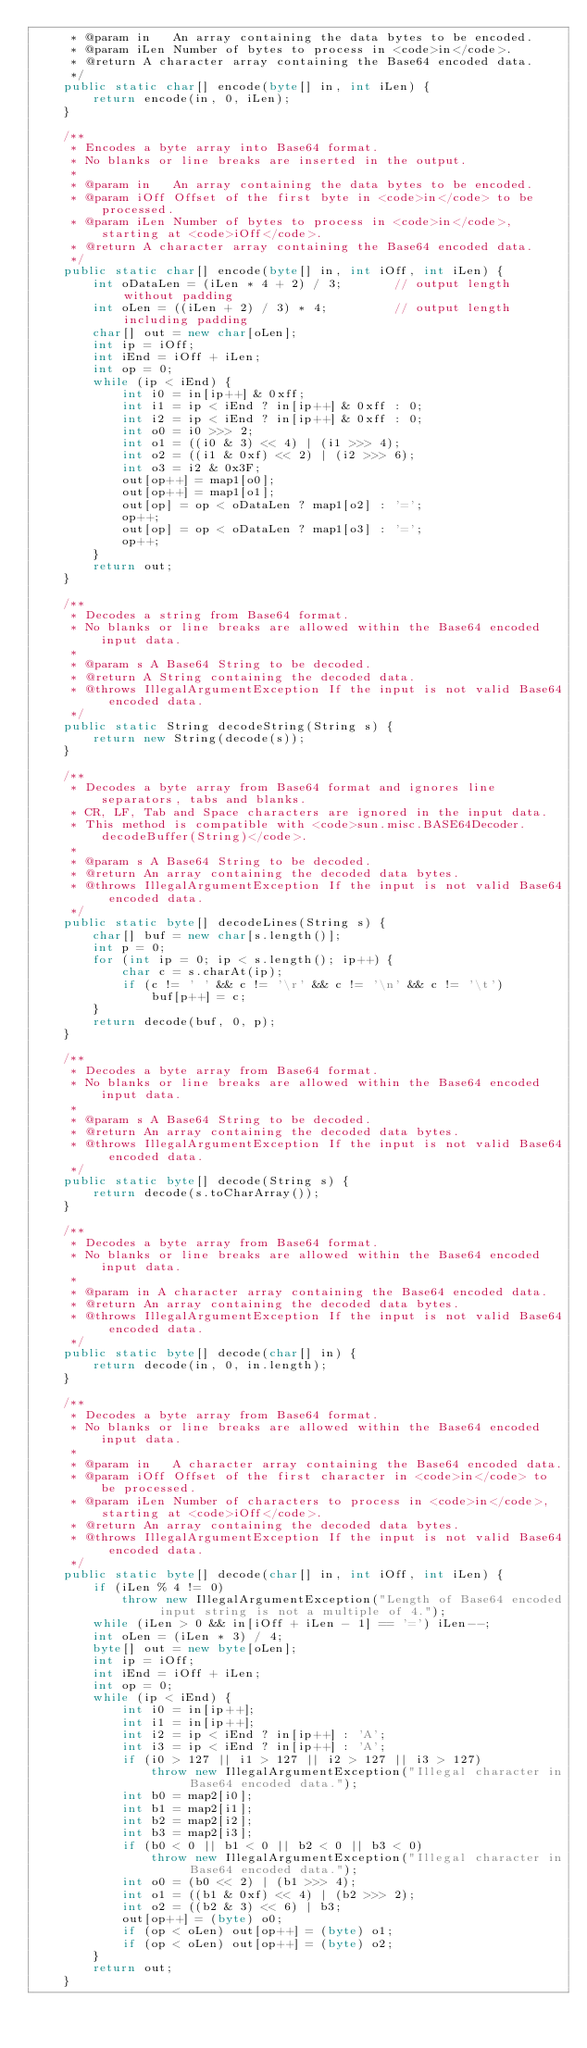<code> <loc_0><loc_0><loc_500><loc_500><_Java_>     * @param in   An array containing the data bytes to be encoded.
     * @param iLen Number of bytes to process in <code>in</code>.
     * @return A character array containing the Base64 encoded data.
     */
    public static char[] encode(byte[] in, int iLen) {
        return encode(in, 0, iLen);
    }

    /**
     * Encodes a byte array into Base64 format.
     * No blanks or line breaks are inserted in the output.
     *
     * @param in   An array containing the data bytes to be encoded.
     * @param iOff Offset of the first byte in <code>in</code> to be processed.
     * @param iLen Number of bytes to process in <code>in</code>, starting at <code>iOff</code>.
     * @return A character array containing the Base64 encoded data.
     */
    public static char[] encode(byte[] in, int iOff, int iLen) {
        int oDataLen = (iLen * 4 + 2) / 3;       // output length without padding
        int oLen = ((iLen + 2) / 3) * 4;         // output length including padding
        char[] out = new char[oLen];
        int ip = iOff;
        int iEnd = iOff + iLen;
        int op = 0;
        while (ip < iEnd) {
            int i0 = in[ip++] & 0xff;
            int i1 = ip < iEnd ? in[ip++] & 0xff : 0;
            int i2 = ip < iEnd ? in[ip++] & 0xff : 0;
            int o0 = i0 >>> 2;
            int o1 = ((i0 & 3) << 4) | (i1 >>> 4);
            int o2 = ((i1 & 0xf) << 2) | (i2 >>> 6);
            int o3 = i2 & 0x3F;
            out[op++] = map1[o0];
            out[op++] = map1[o1];
            out[op] = op < oDataLen ? map1[o2] : '=';
            op++;
            out[op] = op < oDataLen ? map1[o3] : '=';
            op++;
        }
        return out;
    }

    /**
     * Decodes a string from Base64 format.
     * No blanks or line breaks are allowed within the Base64 encoded input data.
     *
     * @param s A Base64 String to be decoded.
     * @return A String containing the decoded data.
     * @throws IllegalArgumentException If the input is not valid Base64 encoded data.
     */
    public static String decodeString(String s) {
        return new String(decode(s));
    }

    /**
     * Decodes a byte array from Base64 format and ignores line separators, tabs and blanks.
     * CR, LF, Tab and Space characters are ignored in the input data.
     * This method is compatible with <code>sun.misc.BASE64Decoder.decodeBuffer(String)</code>.
     *
     * @param s A Base64 String to be decoded.
     * @return An array containing the decoded data bytes.
     * @throws IllegalArgumentException If the input is not valid Base64 encoded data.
     */
    public static byte[] decodeLines(String s) {
        char[] buf = new char[s.length()];
        int p = 0;
        for (int ip = 0; ip < s.length(); ip++) {
            char c = s.charAt(ip);
            if (c != ' ' && c != '\r' && c != '\n' && c != '\t')
                buf[p++] = c;
        }
        return decode(buf, 0, p);
    }

    /**
     * Decodes a byte array from Base64 format.
     * No blanks or line breaks are allowed within the Base64 encoded input data.
     *
     * @param s A Base64 String to be decoded.
     * @return An array containing the decoded data bytes.
     * @throws IllegalArgumentException If the input is not valid Base64 encoded data.
     */
    public static byte[] decode(String s) {
        return decode(s.toCharArray());
    }

    /**
     * Decodes a byte array from Base64 format.
     * No blanks or line breaks are allowed within the Base64 encoded input data.
     *
     * @param in A character array containing the Base64 encoded data.
     * @return An array containing the decoded data bytes.
     * @throws IllegalArgumentException If the input is not valid Base64 encoded data.
     */
    public static byte[] decode(char[] in) {
        return decode(in, 0, in.length);
    }

    /**
     * Decodes a byte array from Base64 format.
     * No blanks or line breaks are allowed within the Base64 encoded input data.
     *
     * @param in   A character array containing the Base64 encoded data.
     * @param iOff Offset of the first character in <code>in</code> to be processed.
     * @param iLen Number of characters to process in <code>in</code>, starting at <code>iOff</code>.
     * @return An array containing the decoded data bytes.
     * @throws IllegalArgumentException If the input is not valid Base64 encoded data.
     */
    public static byte[] decode(char[] in, int iOff, int iLen) {
        if (iLen % 4 != 0)
            throw new IllegalArgumentException("Length of Base64 encoded input string is not a multiple of 4.");
        while (iLen > 0 && in[iOff + iLen - 1] == '=') iLen--;
        int oLen = (iLen * 3) / 4;
        byte[] out = new byte[oLen];
        int ip = iOff;
        int iEnd = iOff + iLen;
        int op = 0;
        while (ip < iEnd) {
            int i0 = in[ip++];
            int i1 = in[ip++];
            int i2 = ip < iEnd ? in[ip++] : 'A';
            int i3 = ip < iEnd ? in[ip++] : 'A';
            if (i0 > 127 || i1 > 127 || i2 > 127 || i3 > 127)
                throw new IllegalArgumentException("Illegal character in Base64 encoded data.");
            int b0 = map2[i0];
            int b1 = map2[i1];
            int b2 = map2[i2];
            int b3 = map2[i3];
            if (b0 < 0 || b1 < 0 || b2 < 0 || b3 < 0)
                throw new IllegalArgumentException("Illegal character in Base64 encoded data.");
            int o0 = (b0 << 2) | (b1 >>> 4);
            int o1 = ((b1 & 0xf) << 4) | (b2 >>> 2);
            int o2 = ((b2 & 3) << 6) | b3;
            out[op++] = (byte) o0;
            if (op < oLen) out[op++] = (byte) o1;
            if (op < oLen) out[op++] = (byte) o2;
        }
        return out;
    }
</code> 